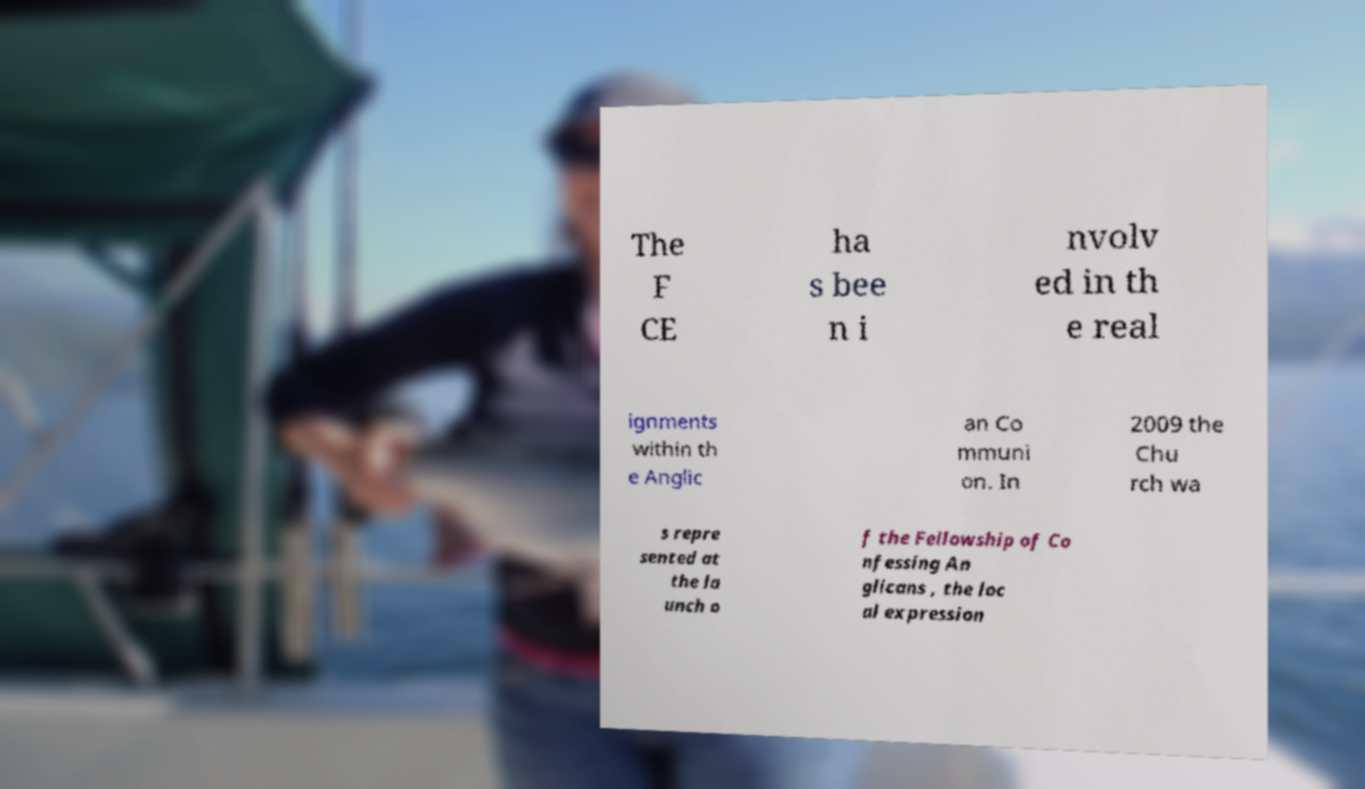Can you accurately transcribe the text from the provided image for me? The F CE ha s bee n i nvolv ed in th e real ignments within th e Anglic an Co mmuni on. In 2009 the Chu rch wa s repre sented at the la unch o f the Fellowship of Co nfessing An glicans , the loc al expression 